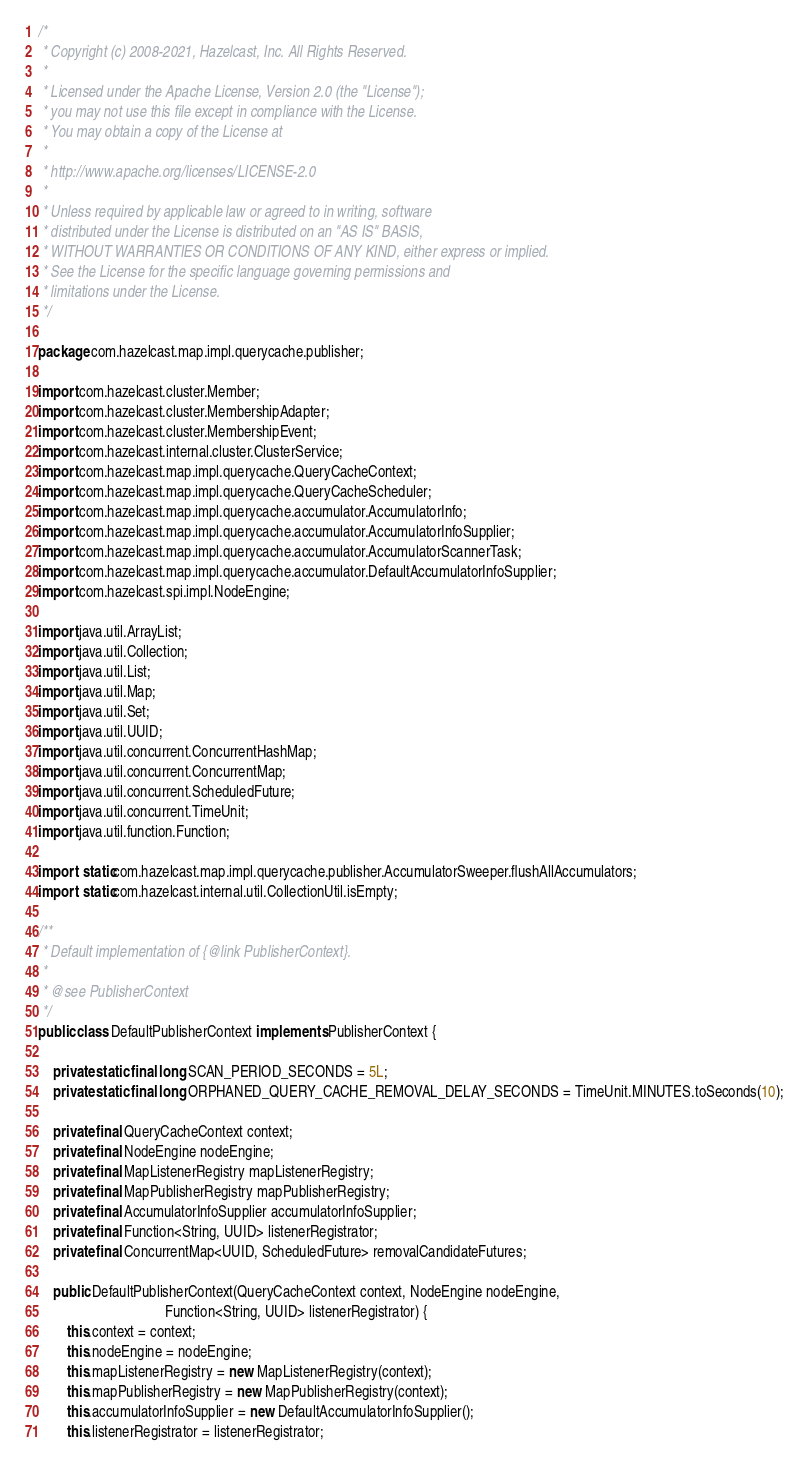Convert code to text. <code><loc_0><loc_0><loc_500><loc_500><_Java_>/*
 * Copyright (c) 2008-2021, Hazelcast, Inc. All Rights Reserved.
 *
 * Licensed under the Apache License, Version 2.0 (the "License");
 * you may not use this file except in compliance with the License.
 * You may obtain a copy of the License at
 *
 * http://www.apache.org/licenses/LICENSE-2.0
 *
 * Unless required by applicable law or agreed to in writing, software
 * distributed under the License is distributed on an "AS IS" BASIS,
 * WITHOUT WARRANTIES OR CONDITIONS OF ANY KIND, either express or implied.
 * See the License for the specific language governing permissions and
 * limitations under the License.
 */

package com.hazelcast.map.impl.querycache.publisher;

import com.hazelcast.cluster.Member;
import com.hazelcast.cluster.MembershipAdapter;
import com.hazelcast.cluster.MembershipEvent;
import com.hazelcast.internal.cluster.ClusterService;
import com.hazelcast.map.impl.querycache.QueryCacheContext;
import com.hazelcast.map.impl.querycache.QueryCacheScheduler;
import com.hazelcast.map.impl.querycache.accumulator.AccumulatorInfo;
import com.hazelcast.map.impl.querycache.accumulator.AccumulatorInfoSupplier;
import com.hazelcast.map.impl.querycache.accumulator.AccumulatorScannerTask;
import com.hazelcast.map.impl.querycache.accumulator.DefaultAccumulatorInfoSupplier;
import com.hazelcast.spi.impl.NodeEngine;

import java.util.ArrayList;
import java.util.Collection;
import java.util.List;
import java.util.Map;
import java.util.Set;
import java.util.UUID;
import java.util.concurrent.ConcurrentHashMap;
import java.util.concurrent.ConcurrentMap;
import java.util.concurrent.ScheduledFuture;
import java.util.concurrent.TimeUnit;
import java.util.function.Function;

import static com.hazelcast.map.impl.querycache.publisher.AccumulatorSweeper.flushAllAccumulators;
import static com.hazelcast.internal.util.CollectionUtil.isEmpty;

/**
 * Default implementation of {@link PublisherContext}.
 *
 * @see PublisherContext
 */
public class DefaultPublisherContext implements PublisherContext {

    private static final long SCAN_PERIOD_SECONDS = 5L;
    private static final long ORPHANED_QUERY_CACHE_REMOVAL_DELAY_SECONDS = TimeUnit.MINUTES.toSeconds(10);

    private final QueryCacheContext context;
    private final NodeEngine nodeEngine;
    private final MapListenerRegistry mapListenerRegistry;
    private final MapPublisherRegistry mapPublisherRegistry;
    private final AccumulatorInfoSupplier accumulatorInfoSupplier;
    private final Function<String, UUID> listenerRegistrator;
    private final ConcurrentMap<UUID, ScheduledFuture> removalCandidateFutures;

    public DefaultPublisherContext(QueryCacheContext context, NodeEngine nodeEngine,
                                   Function<String, UUID> listenerRegistrator) {
        this.context = context;
        this.nodeEngine = nodeEngine;
        this.mapListenerRegistry = new MapListenerRegistry(context);
        this.mapPublisherRegistry = new MapPublisherRegistry(context);
        this.accumulatorInfoSupplier = new DefaultAccumulatorInfoSupplier();
        this.listenerRegistrator = listenerRegistrator;</code> 